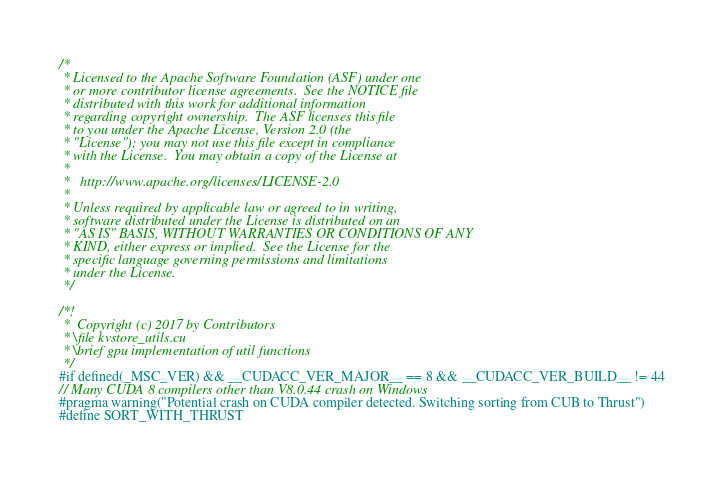Convert code to text. <code><loc_0><loc_0><loc_500><loc_500><_Cuda_>/*
 * Licensed to the Apache Software Foundation (ASF) under one
 * or more contributor license agreements.  See the NOTICE file
 * distributed with this work for additional information
 * regarding copyright ownership.  The ASF licenses this file
 * to you under the Apache License, Version 2.0 (the
 * "License"); you may not use this file except in compliance
 * with the License.  You may obtain a copy of the License at
 *
 *   http://www.apache.org/licenses/LICENSE-2.0
 *
 * Unless required by applicable law or agreed to in writing,
 * software distributed under the License is distributed on an
 * "AS IS" BASIS, WITHOUT WARRANTIES OR CONDITIONS OF ANY
 * KIND, either express or implied.  See the License for the
 * specific language governing permissions and limitations
 * under the License.
 */

/*!
 *  Copyright (c) 2017 by Contributors
 * \file kvstore_utils.cu
 * \brief gpu implementation of util functions
 */
#if defined(_MSC_VER) && __CUDACC_VER_MAJOR__ == 8 && __CUDACC_VER_BUILD__ != 44
// Many CUDA 8 compilers other than V8.0.44 crash on Windows
#pragma warning("Potential crash on CUDA compiler detected. Switching sorting from CUB to Thrust")
#define SORT_WITH_THRUST</code> 